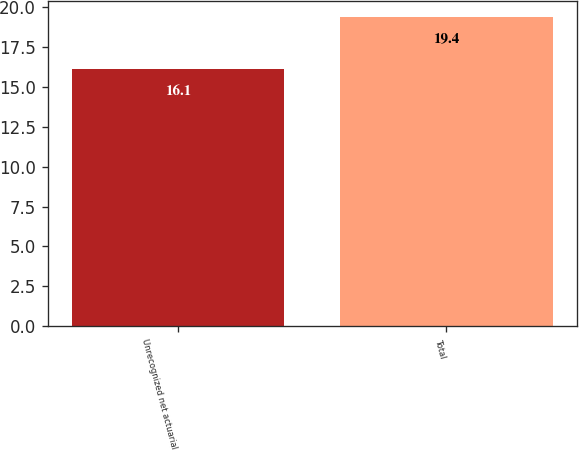Convert chart to OTSL. <chart><loc_0><loc_0><loc_500><loc_500><bar_chart><fcel>Unrecognized net actuarial<fcel>Total<nl><fcel>16.1<fcel>19.4<nl></chart> 